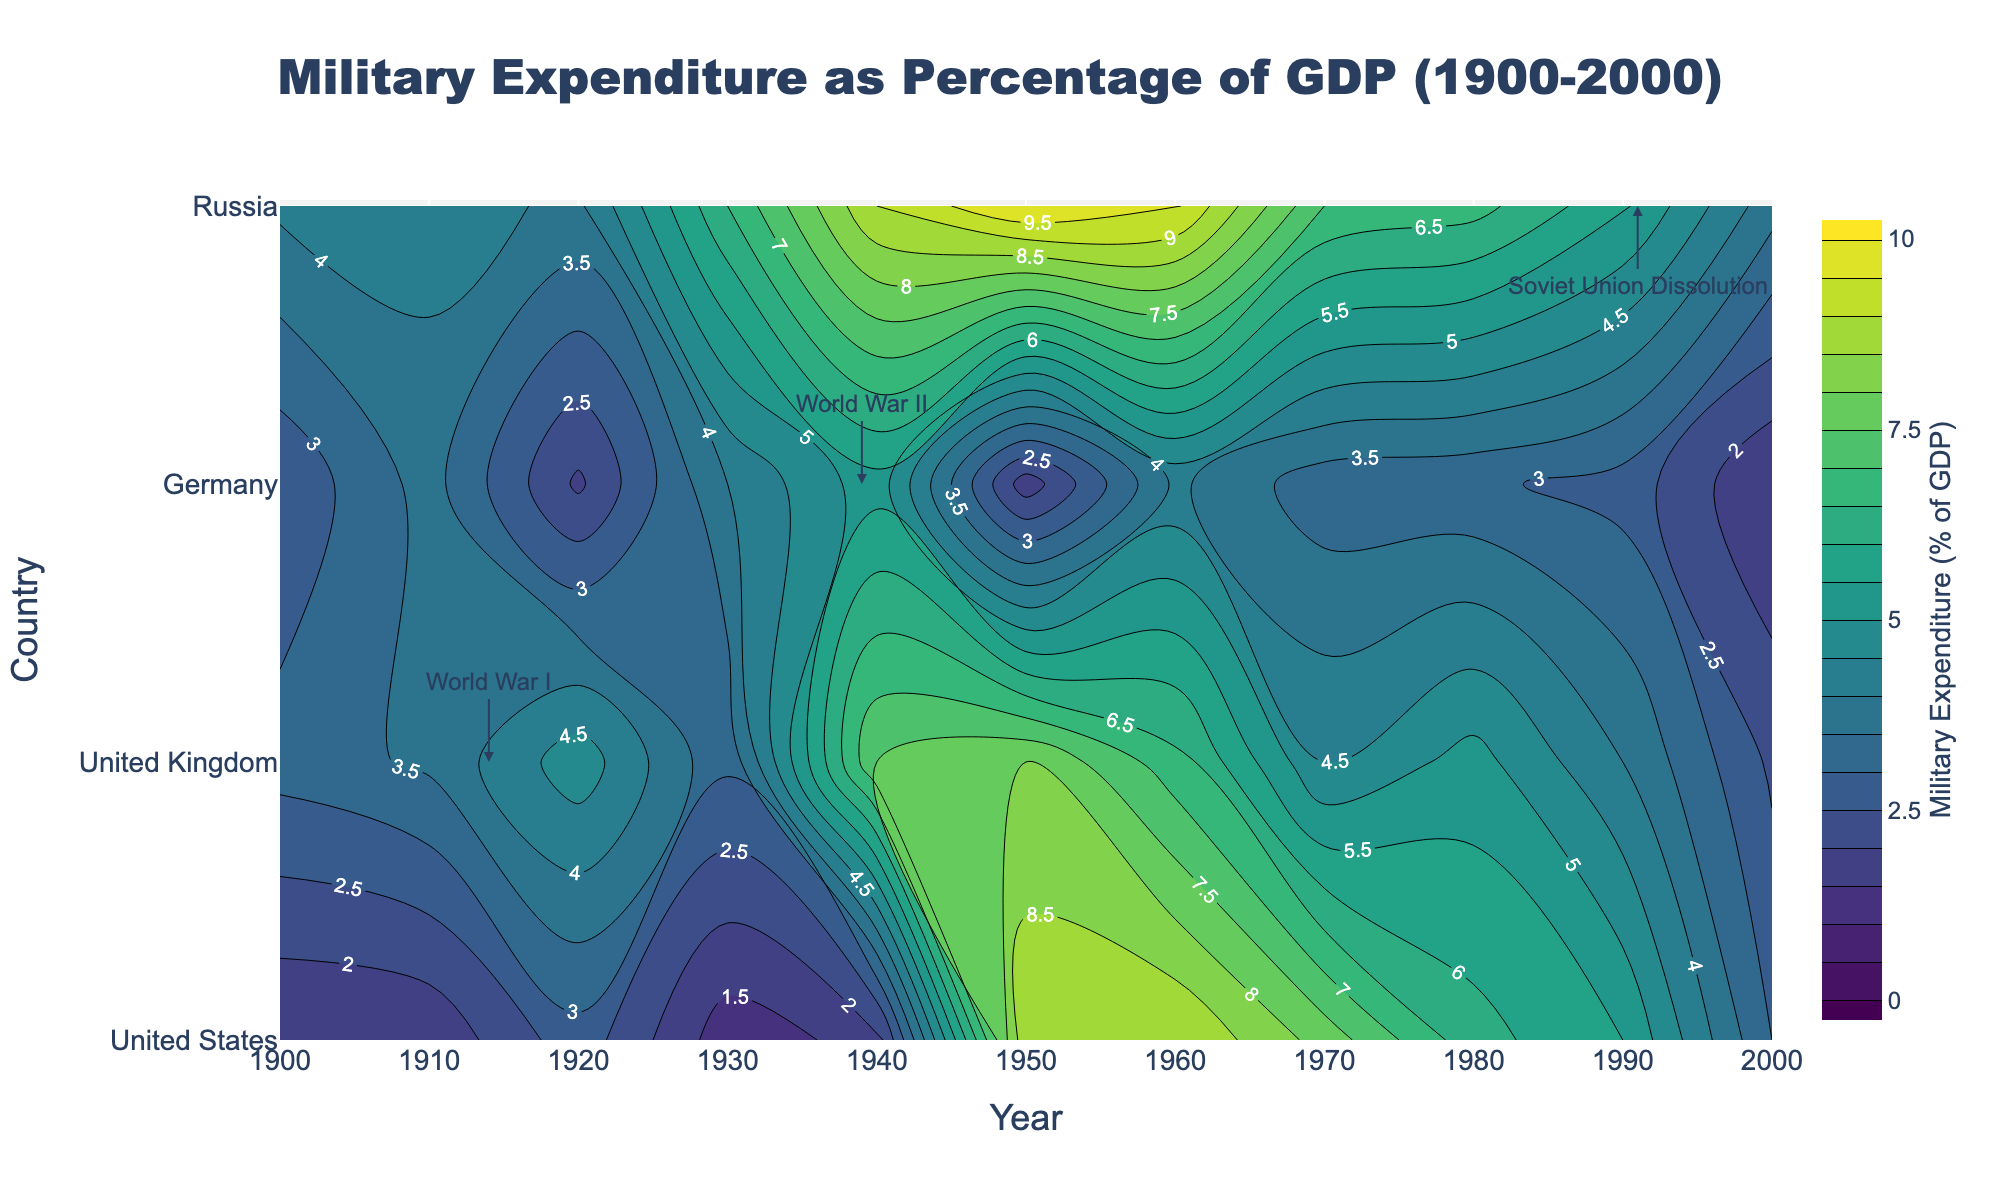What is the title of the figure? The title of the figure is usually located at the top, centered above the main plot. In this case, by reading the title text, we find the title to be "Military Expenditure as Percentage of GDP (1900-2000)".
Answer: Military Expenditure as Percentage of GDP (1900-2000) Which country had the highest military expenditure as a percentage of GDP in 1950? To find this information, look at the 1950 vertical section and identify the highest contour value. From the contour plot, Russia had the highest military expenditure at around 10.0% in 1950.
Answer: Russia During which event does the annotation for 'World War I' appear, and which country does it point to? The annotation for 'World War I' appears around the year 1914 and points to the United Kingdom. This can be inferred from the placement of the annotation in the plot.
Answer: World War I, United Kingdom How does the military expenditure percentage for the United States compare between 1900 and 2000? By looking at the contour lines for the United States in 1900 and 2000, you can see that the military expenditure was 1.5% in 1900 and increased to 3.0% in 2000. You compare these two values to see the increase.
Answer: 1.5% in 1900 and 3.0% in 2000 What is the color scale used in the contour plot to represent military expenditure? The color scale used in the contour plot is 'Viridis'. This can be identified by examining the color gradient from the legend beside the plot.
Answer: Viridis Which period shows the highest military expenditure for Germany? To determine this, observe the contour lines for Germany over the years. The highest expenditure for Germany is seen around 1940, with a value of 5.3%.
Answer: 1940 Can you identify the key event annotation that appears around 1991 and the country it is associated with? The annotation around 1991 points to Russia and corresponds to the event "Soviet Union Dissolution". This can be deduced from the plot annotations.
Answer: Soviet Union Dissolution, Russia Which countries had a higher military expenditure percentage than 5% of GDP during World War II (1939-1945)? Inspecting the contours during the 1939-1945 period shows that Germany (5.3%), Russia (9.0%), and the United Kingdom (7.5%) had military expenditures higher than 5% of GDP.
Answer: Germany, Russia, United Kingdom Compare the trends of military expenditure percentages for the United Kingdom and Germany between 1950 and 1970. Who had a more consistent decline? By examining the contour lines from 1950 to 1970, we see the United Kingdom's expenditure declined more consistently from 8.0% to 4.5%, whereas Germany had fluctuations.
Answer: United Kingdom What could be inferred about the military expenditure trends in Russia from 1940 to 1990? From 1940 to 1990, the contour lines for Russia show high expenditures, peaking around 1950 (10.0%) and generally decreasing to 5.6% by 1990. This suggests a decline in relative military spending over time.
Answer: High then declining 